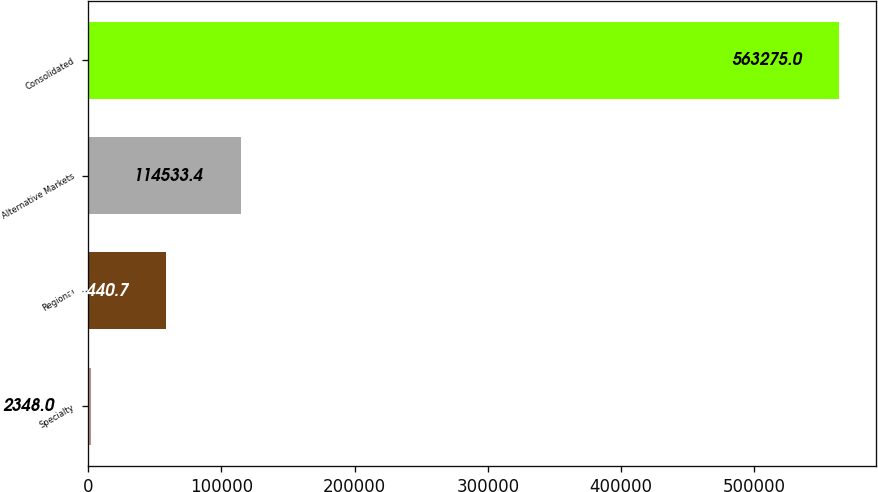<chart> <loc_0><loc_0><loc_500><loc_500><bar_chart><fcel>Specialty<fcel>Regional<fcel>Alternative Markets<fcel>Consolidated<nl><fcel>2348<fcel>58440.7<fcel>114533<fcel>563275<nl></chart> 